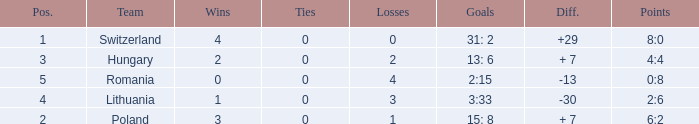Which team had fewer than 2 losses and a position number more than 1? Poland. 